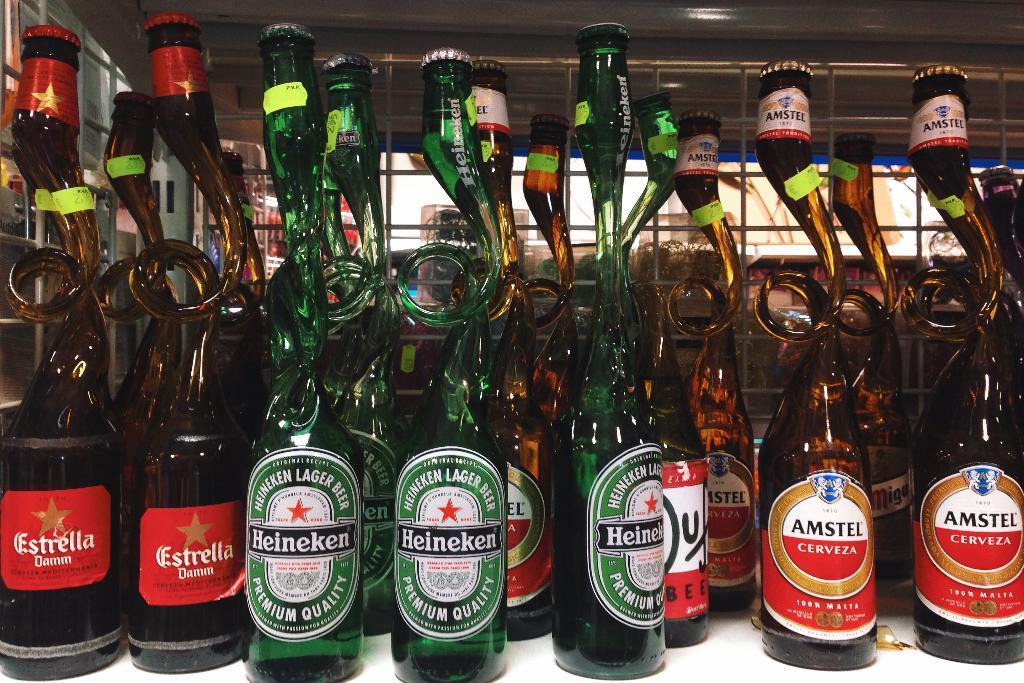Please provide a concise description of this image. In this picture we can see couple of bottles on the tables. 